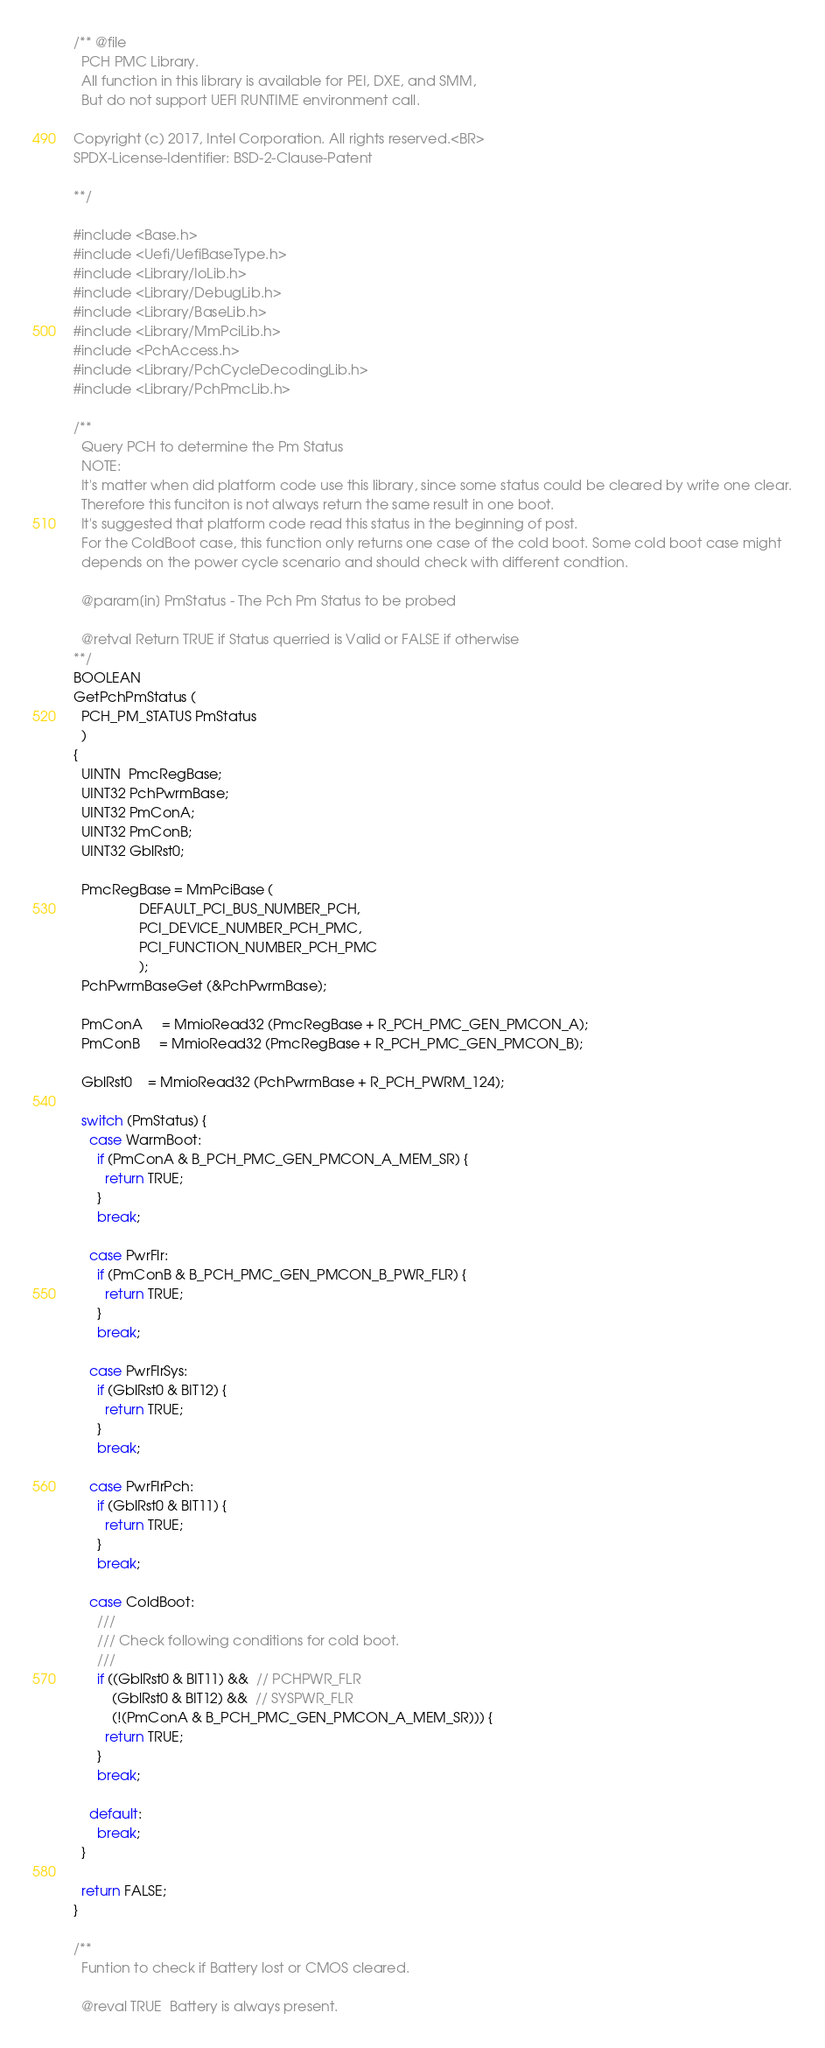Convert code to text. <code><loc_0><loc_0><loc_500><loc_500><_C_>/** @file
  PCH PMC Library.
  All function in this library is available for PEI, DXE, and SMM,
  But do not support UEFI RUNTIME environment call.

Copyright (c) 2017, Intel Corporation. All rights reserved.<BR>
SPDX-License-Identifier: BSD-2-Clause-Patent

**/

#include <Base.h>
#include <Uefi/UefiBaseType.h>
#include <Library/IoLib.h>
#include <Library/DebugLib.h>
#include <Library/BaseLib.h>
#include <Library/MmPciLib.h>
#include <PchAccess.h>
#include <Library/PchCycleDecodingLib.h>
#include <Library/PchPmcLib.h>

/**
  Query PCH to determine the Pm Status
  NOTE:
  It's matter when did platform code use this library, since some status could be cleared by write one clear.
  Therefore this funciton is not always return the same result in one boot.
  It's suggested that platform code read this status in the beginning of post.
  For the ColdBoot case, this function only returns one case of the cold boot. Some cold boot case might
  depends on the power cycle scenario and should check with different condtion.

  @param[in] PmStatus - The Pch Pm Status to be probed

  @retval Return TRUE if Status querried is Valid or FALSE if otherwise
**/
BOOLEAN
GetPchPmStatus (
  PCH_PM_STATUS PmStatus
  )
{
  UINTN  PmcRegBase;
  UINT32 PchPwrmBase;
  UINT32 PmConA;
  UINT32 PmConB;
  UINT32 GblRst0;

  PmcRegBase = MmPciBase (
                 DEFAULT_PCI_BUS_NUMBER_PCH,
                 PCI_DEVICE_NUMBER_PCH_PMC,
                 PCI_FUNCTION_NUMBER_PCH_PMC
                 );
  PchPwrmBaseGet (&PchPwrmBase);

  PmConA     = MmioRead32 (PmcRegBase + R_PCH_PMC_GEN_PMCON_A);
  PmConB     = MmioRead32 (PmcRegBase + R_PCH_PMC_GEN_PMCON_B);

  GblRst0    = MmioRead32 (PchPwrmBase + R_PCH_PWRM_124);

  switch (PmStatus) {
    case WarmBoot:
      if (PmConA & B_PCH_PMC_GEN_PMCON_A_MEM_SR) {
        return TRUE;
      }
      break;

    case PwrFlr:
      if (PmConB & B_PCH_PMC_GEN_PMCON_B_PWR_FLR) {
        return TRUE;
      }
      break;

    case PwrFlrSys:
      if (GblRst0 & BIT12) {
        return TRUE;
      }
      break;

    case PwrFlrPch:
      if (GblRst0 & BIT11) {
        return TRUE;
      }
      break;

    case ColdBoot:
      ///
      /// Check following conditions for cold boot.
      ///
      if ((GblRst0 & BIT11) &&  // PCHPWR_FLR
          (GblRst0 & BIT12) &&  // SYSPWR_FLR
          (!(PmConA & B_PCH_PMC_GEN_PMCON_A_MEM_SR))) {
        return TRUE;
      }
      break;

    default:
      break;
  }

  return FALSE;
}

/**
  Funtion to check if Battery lost or CMOS cleared.

  @reval TRUE  Battery is always present.</code> 